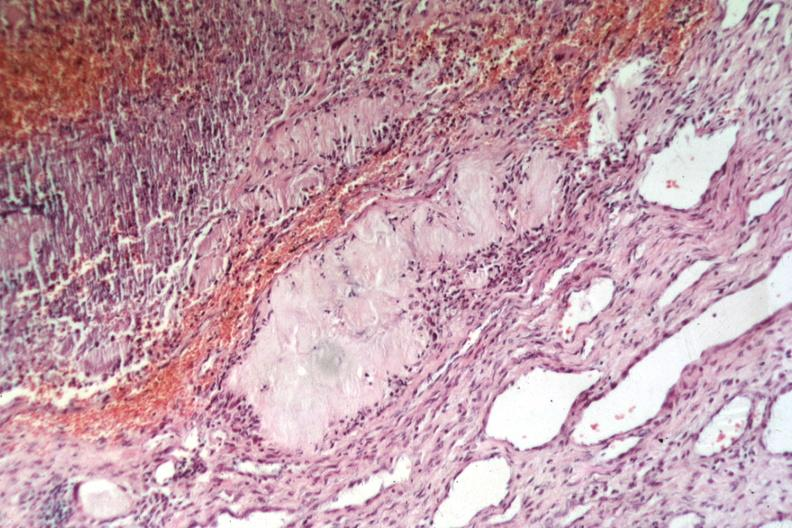where is this?
Answer the question using a single word or phrase. Skin 